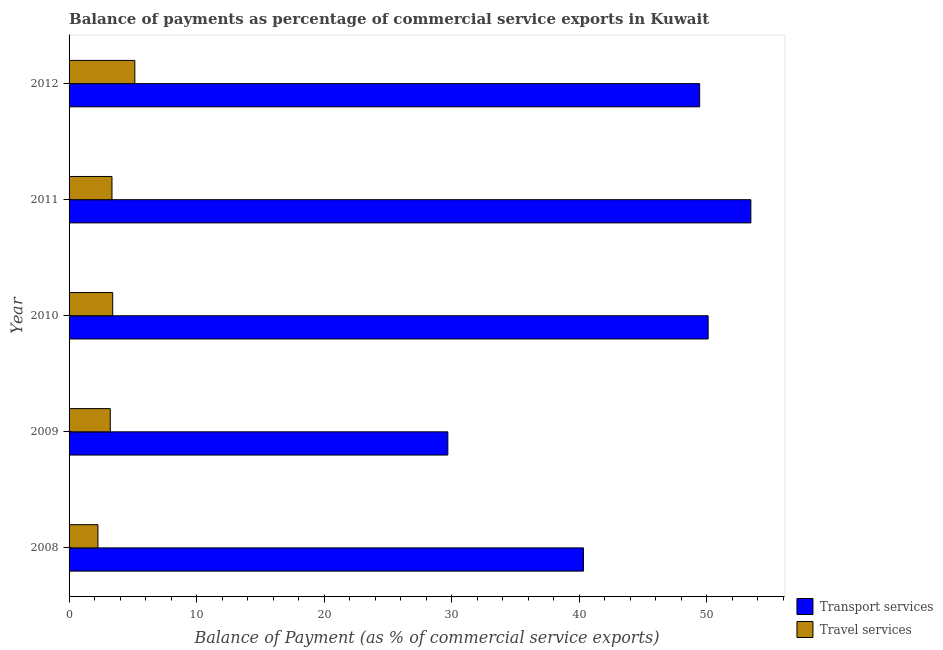How many groups of bars are there?
Your answer should be compact. 5. Are the number of bars on each tick of the Y-axis equal?
Your response must be concise. Yes. How many bars are there on the 2nd tick from the top?
Provide a short and direct response. 2. What is the label of the 3rd group of bars from the top?
Make the answer very short. 2010. What is the balance of payments of travel services in 2010?
Ensure brevity in your answer.  3.42. Across all years, what is the maximum balance of payments of transport services?
Your response must be concise. 53.48. Across all years, what is the minimum balance of payments of transport services?
Provide a succinct answer. 29.71. What is the total balance of payments of transport services in the graph?
Your answer should be very brief. 223.12. What is the difference between the balance of payments of travel services in 2009 and that in 2010?
Your response must be concise. -0.19. What is the difference between the balance of payments of travel services in 2012 and the balance of payments of transport services in 2010?
Your answer should be very brief. -44.97. What is the average balance of payments of transport services per year?
Your answer should be very brief. 44.62. In the year 2008, what is the difference between the balance of payments of travel services and balance of payments of transport services?
Offer a terse response. -38.08. In how many years, is the balance of payments of transport services greater than 32 %?
Keep it short and to the point. 4. What is the ratio of the balance of payments of travel services in 2011 to that in 2012?
Give a very brief answer. 0.65. Is the difference between the balance of payments of travel services in 2010 and 2011 greater than the difference between the balance of payments of transport services in 2010 and 2011?
Give a very brief answer. Yes. What is the difference between the highest and the second highest balance of payments of transport services?
Ensure brevity in your answer.  3.35. What is the difference between the highest and the lowest balance of payments of travel services?
Offer a terse response. 2.89. In how many years, is the balance of payments of travel services greater than the average balance of payments of travel services taken over all years?
Make the answer very short. 1. What does the 1st bar from the top in 2011 represents?
Offer a terse response. Travel services. What does the 1st bar from the bottom in 2011 represents?
Your response must be concise. Transport services. How many bars are there?
Offer a very short reply. 10. Are all the bars in the graph horizontal?
Your response must be concise. Yes. Does the graph contain any zero values?
Your answer should be compact. No. Where does the legend appear in the graph?
Offer a terse response. Bottom right. How many legend labels are there?
Your answer should be compact. 2. How are the legend labels stacked?
Your response must be concise. Vertical. What is the title of the graph?
Offer a terse response. Balance of payments as percentage of commercial service exports in Kuwait. Does "Drinking water services" appear as one of the legend labels in the graph?
Offer a very short reply. No. What is the label or title of the X-axis?
Your response must be concise. Balance of Payment (as % of commercial service exports). What is the label or title of the Y-axis?
Ensure brevity in your answer.  Year. What is the Balance of Payment (as % of commercial service exports) of Transport services in 2008?
Provide a short and direct response. 40.35. What is the Balance of Payment (as % of commercial service exports) in Travel services in 2008?
Your answer should be compact. 2.27. What is the Balance of Payment (as % of commercial service exports) in Transport services in 2009?
Provide a succinct answer. 29.71. What is the Balance of Payment (as % of commercial service exports) in Travel services in 2009?
Make the answer very short. 3.23. What is the Balance of Payment (as % of commercial service exports) of Transport services in 2010?
Provide a succinct answer. 50.13. What is the Balance of Payment (as % of commercial service exports) of Travel services in 2010?
Offer a very short reply. 3.42. What is the Balance of Payment (as % of commercial service exports) of Transport services in 2011?
Your answer should be compact. 53.48. What is the Balance of Payment (as % of commercial service exports) of Travel services in 2011?
Make the answer very short. 3.37. What is the Balance of Payment (as % of commercial service exports) in Transport services in 2012?
Keep it short and to the point. 49.46. What is the Balance of Payment (as % of commercial service exports) in Travel services in 2012?
Provide a short and direct response. 5.16. Across all years, what is the maximum Balance of Payment (as % of commercial service exports) of Transport services?
Offer a terse response. 53.48. Across all years, what is the maximum Balance of Payment (as % of commercial service exports) of Travel services?
Your response must be concise. 5.16. Across all years, what is the minimum Balance of Payment (as % of commercial service exports) of Transport services?
Offer a very short reply. 29.71. Across all years, what is the minimum Balance of Payment (as % of commercial service exports) of Travel services?
Your answer should be compact. 2.27. What is the total Balance of Payment (as % of commercial service exports) of Transport services in the graph?
Your answer should be compact. 223.12. What is the total Balance of Payment (as % of commercial service exports) in Travel services in the graph?
Make the answer very short. 17.44. What is the difference between the Balance of Payment (as % of commercial service exports) in Transport services in 2008 and that in 2009?
Give a very brief answer. 10.64. What is the difference between the Balance of Payment (as % of commercial service exports) of Travel services in 2008 and that in 2009?
Offer a very short reply. -0.97. What is the difference between the Balance of Payment (as % of commercial service exports) in Transport services in 2008 and that in 2010?
Your answer should be very brief. -9.78. What is the difference between the Balance of Payment (as % of commercial service exports) of Travel services in 2008 and that in 2010?
Offer a terse response. -1.16. What is the difference between the Balance of Payment (as % of commercial service exports) in Transport services in 2008 and that in 2011?
Provide a succinct answer. -13.13. What is the difference between the Balance of Payment (as % of commercial service exports) in Travel services in 2008 and that in 2011?
Give a very brief answer. -1.1. What is the difference between the Balance of Payment (as % of commercial service exports) of Transport services in 2008 and that in 2012?
Your answer should be very brief. -9.11. What is the difference between the Balance of Payment (as % of commercial service exports) in Travel services in 2008 and that in 2012?
Offer a very short reply. -2.89. What is the difference between the Balance of Payment (as % of commercial service exports) in Transport services in 2009 and that in 2010?
Offer a very short reply. -20.42. What is the difference between the Balance of Payment (as % of commercial service exports) in Travel services in 2009 and that in 2010?
Keep it short and to the point. -0.19. What is the difference between the Balance of Payment (as % of commercial service exports) of Transport services in 2009 and that in 2011?
Your answer should be very brief. -23.77. What is the difference between the Balance of Payment (as % of commercial service exports) of Travel services in 2009 and that in 2011?
Your answer should be compact. -0.14. What is the difference between the Balance of Payment (as % of commercial service exports) of Transport services in 2009 and that in 2012?
Ensure brevity in your answer.  -19.75. What is the difference between the Balance of Payment (as % of commercial service exports) in Travel services in 2009 and that in 2012?
Provide a short and direct response. -1.93. What is the difference between the Balance of Payment (as % of commercial service exports) in Transport services in 2010 and that in 2011?
Provide a succinct answer. -3.35. What is the difference between the Balance of Payment (as % of commercial service exports) in Travel services in 2010 and that in 2011?
Offer a terse response. 0.06. What is the difference between the Balance of Payment (as % of commercial service exports) in Transport services in 2010 and that in 2012?
Your response must be concise. 0.67. What is the difference between the Balance of Payment (as % of commercial service exports) of Travel services in 2010 and that in 2012?
Give a very brief answer. -1.73. What is the difference between the Balance of Payment (as % of commercial service exports) in Transport services in 2011 and that in 2012?
Make the answer very short. 4.02. What is the difference between the Balance of Payment (as % of commercial service exports) of Travel services in 2011 and that in 2012?
Ensure brevity in your answer.  -1.79. What is the difference between the Balance of Payment (as % of commercial service exports) of Transport services in 2008 and the Balance of Payment (as % of commercial service exports) of Travel services in 2009?
Provide a succinct answer. 37.12. What is the difference between the Balance of Payment (as % of commercial service exports) in Transport services in 2008 and the Balance of Payment (as % of commercial service exports) in Travel services in 2010?
Provide a short and direct response. 36.92. What is the difference between the Balance of Payment (as % of commercial service exports) in Transport services in 2008 and the Balance of Payment (as % of commercial service exports) in Travel services in 2011?
Provide a short and direct response. 36.98. What is the difference between the Balance of Payment (as % of commercial service exports) in Transport services in 2008 and the Balance of Payment (as % of commercial service exports) in Travel services in 2012?
Make the answer very short. 35.19. What is the difference between the Balance of Payment (as % of commercial service exports) in Transport services in 2009 and the Balance of Payment (as % of commercial service exports) in Travel services in 2010?
Offer a very short reply. 26.29. What is the difference between the Balance of Payment (as % of commercial service exports) in Transport services in 2009 and the Balance of Payment (as % of commercial service exports) in Travel services in 2011?
Ensure brevity in your answer.  26.34. What is the difference between the Balance of Payment (as % of commercial service exports) of Transport services in 2009 and the Balance of Payment (as % of commercial service exports) of Travel services in 2012?
Provide a succinct answer. 24.55. What is the difference between the Balance of Payment (as % of commercial service exports) of Transport services in 2010 and the Balance of Payment (as % of commercial service exports) of Travel services in 2011?
Offer a very short reply. 46.76. What is the difference between the Balance of Payment (as % of commercial service exports) of Transport services in 2010 and the Balance of Payment (as % of commercial service exports) of Travel services in 2012?
Your answer should be compact. 44.97. What is the difference between the Balance of Payment (as % of commercial service exports) in Transport services in 2011 and the Balance of Payment (as % of commercial service exports) in Travel services in 2012?
Ensure brevity in your answer.  48.32. What is the average Balance of Payment (as % of commercial service exports) of Transport services per year?
Provide a succinct answer. 44.62. What is the average Balance of Payment (as % of commercial service exports) of Travel services per year?
Your response must be concise. 3.49. In the year 2008, what is the difference between the Balance of Payment (as % of commercial service exports) of Transport services and Balance of Payment (as % of commercial service exports) of Travel services?
Keep it short and to the point. 38.08. In the year 2009, what is the difference between the Balance of Payment (as % of commercial service exports) of Transport services and Balance of Payment (as % of commercial service exports) of Travel services?
Your response must be concise. 26.48. In the year 2010, what is the difference between the Balance of Payment (as % of commercial service exports) in Transport services and Balance of Payment (as % of commercial service exports) in Travel services?
Your answer should be very brief. 46.7. In the year 2011, what is the difference between the Balance of Payment (as % of commercial service exports) of Transport services and Balance of Payment (as % of commercial service exports) of Travel services?
Your answer should be very brief. 50.11. In the year 2012, what is the difference between the Balance of Payment (as % of commercial service exports) in Transport services and Balance of Payment (as % of commercial service exports) in Travel services?
Keep it short and to the point. 44.3. What is the ratio of the Balance of Payment (as % of commercial service exports) of Transport services in 2008 to that in 2009?
Provide a succinct answer. 1.36. What is the ratio of the Balance of Payment (as % of commercial service exports) of Travel services in 2008 to that in 2009?
Give a very brief answer. 0.7. What is the ratio of the Balance of Payment (as % of commercial service exports) in Transport services in 2008 to that in 2010?
Offer a terse response. 0.8. What is the ratio of the Balance of Payment (as % of commercial service exports) in Travel services in 2008 to that in 2010?
Provide a short and direct response. 0.66. What is the ratio of the Balance of Payment (as % of commercial service exports) of Transport services in 2008 to that in 2011?
Give a very brief answer. 0.75. What is the ratio of the Balance of Payment (as % of commercial service exports) of Travel services in 2008 to that in 2011?
Give a very brief answer. 0.67. What is the ratio of the Balance of Payment (as % of commercial service exports) in Transport services in 2008 to that in 2012?
Give a very brief answer. 0.82. What is the ratio of the Balance of Payment (as % of commercial service exports) in Travel services in 2008 to that in 2012?
Keep it short and to the point. 0.44. What is the ratio of the Balance of Payment (as % of commercial service exports) in Transport services in 2009 to that in 2010?
Offer a very short reply. 0.59. What is the ratio of the Balance of Payment (as % of commercial service exports) of Travel services in 2009 to that in 2010?
Ensure brevity in your answer.  0.94. What is the ratio of the Balance of Payment (as % of commercial service exports) of Transport services in 2009 to that in 2011?
Provide a succinct answer. 0.56. What is the ratio of the Balance of Payment (as % of commercial service exports) of Travel services in 2009 to that in 2011?
Your answer should be compact. 0.96. What is the ratio of the Balance of Payment (as % of commercial service exports) of Transport services in 2009 to that in 2012?
Make the answer very short. 0.6. What is the ratio of the Balance of Payment (as % of commercial service exports) in Travel services in 2009 to that in 2012?
Provide a succinct answer. 0.63. What is the ratio of the Balance of Payment (as % of commercial service exports) in Transport services in 2010 to that in 2011?
Keep it short and to the point. 0.94. What is the ratio of the Balance of Payment (as % of commercial service exports) of Travel services in 2010 to that in 2011?
Ensure brevity in your answer.  1.02. What is the ratio of the Balance of Payment (as % of commercial service exports) in Transport services in 2010 to that in 2012?
Make the answer very short. 1.01. What is the ratio of the Balance of Payment (as % of commercial service exports) in Travel services in 2010 to that in 2012?
Your answer should be compact. 0.66. What is the ratio of the Balance of Payment (as % of commercial service exports) in Transport services in 2011 to that in 2012?
Offer a terse response. 1.08. What is the ratio of the Balance of Payment (as % of commercial service exports) of Travel services in 2011 to that in 2012?
Ensure brevity in your answer.  0.65. What is the difference between the highest and the second highest Balance of Payment (as % of commercial service exports) in Transport services?
Give a very brief answer. 3.35. What is the difference between the highest and the second highest Balance of Payment (as % of commercial service exports) of Travel services?
Ensure brevity in your answer.  1.73. What is the difference between the highest and the lowest Balance of Payment (as % of commercial service exports) in Transport services?
Provide a short and direct response. 23.77. What is the difference between the highest and the lowest Balance of Payment (as % of commercial service exports) of Travel services?
Provide a succinct answer. 2.89. 